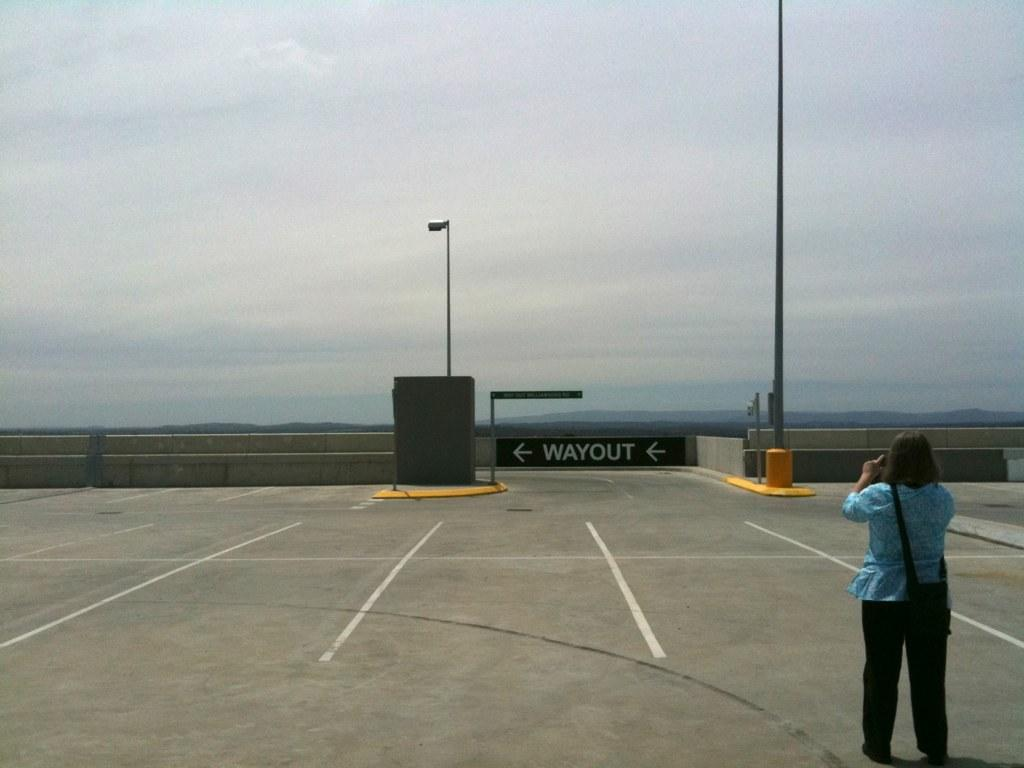Where is the woman located in the image? The woman is standing in the bottom right side of the image. What is the woman holding in her hand? The woman is holding something in her hand, but the specific object cannot be determined from the facts provided. What type of structures can be seen in the image? There are poles and fencing in the image. What is visible in the sky in the image? There are clouds visible in the sky. What type of jam is the woman spreading on the sack in the image? There is no jam or sack present in the image. Can you describe the woman's ear in the image? The facts provided do not mention the woman's ear, so it cannot be described. 